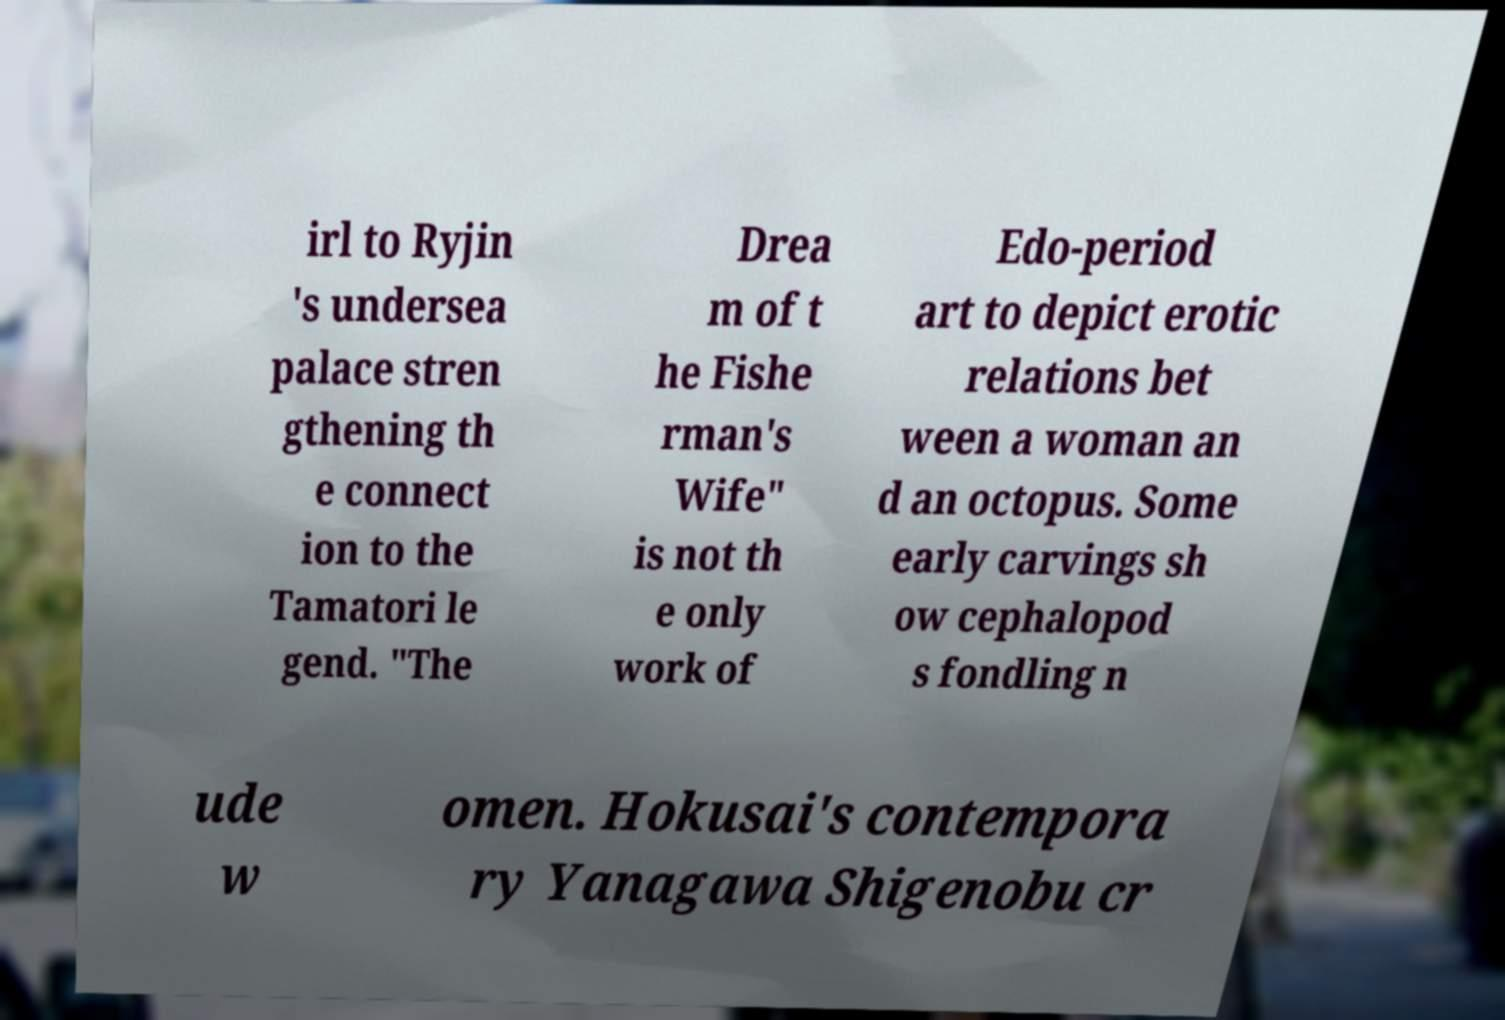There's text embedded in this image that I need extracted. Can you transcribe it verbatim? irl to Ryjin 's undersea palace stren gthening th e connect ion to the Tamatori le gend. "The Drea m of t he Fishe rman's Wife" is not th e only work of Edo-period art to depict erotic relations bet ween a woman an d an octopus. Some early carvings sh ow cephalopod s fondling n ude w omen. Hokusai's contempora ry Yanagawa Shigenobu cr 